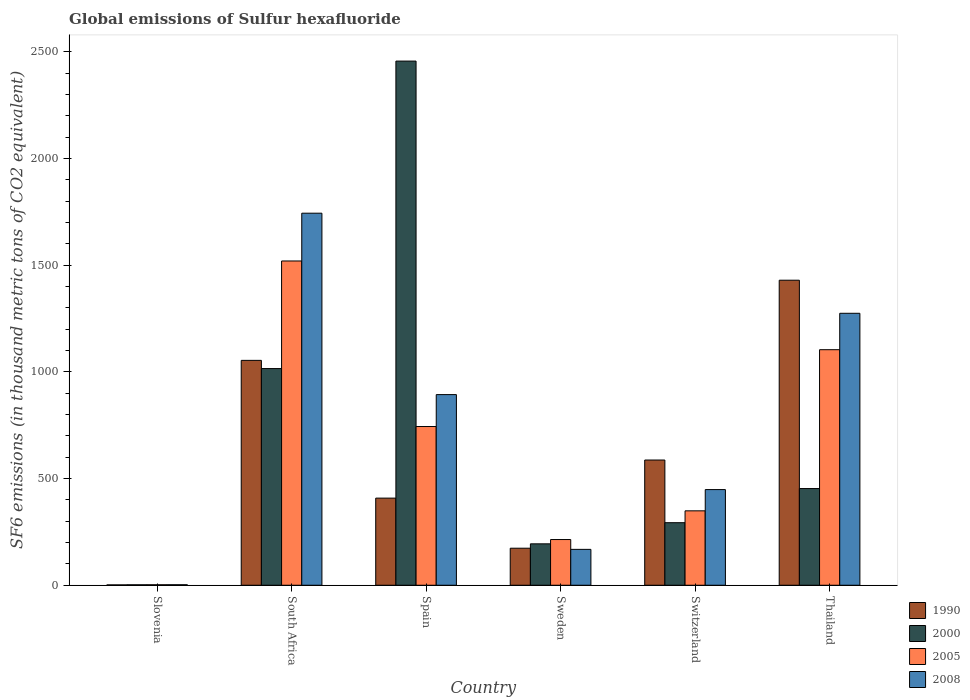Are the number of bars per tick equal to the number of legend labels?
Make the answer very short. Yes. Are the number of bars on each tick of the X-axis equal?
Offer a very short reply. Yes. How many bars are there on the 2nd tick from the left?
Provide a short and direct response. 4. How many bars are there on the 2nd tick from the right?
Your answer should be very brief. 4. In how many cases, is the number of bars for a given country not equal to the number of legend labels?
Give a very brief answer. 0. What is the global emissions of Sulfur hexafluoride in 2008 in Switzerland?
Give a very brief answer. 448.3. Across all countries, what is the maximum global emissions of Sulfur hexafluoride in 2008?
Your answer should be compact. 1743.6. In which country was the global emissions of Sulfur hexafluoride in 2005 maximum?
Your answer should be very brief. South Africa. In which country was the global emissions of Sulfur hexafluoride in 2008 minimum?
Your answer should be very brief. Slovenia. What is the total global emissions of Sulfur hexafluoride in 2000 in the graph?
Your answer should be compact. 4414.1. What is the difference between the global emissions of Sulfur hexafluoride in 2000 in South Africa and that in Switzerland?
Offer a very short reply. 722.3. What is the difference between the global emissions of Sulfur hexafluoride in 1990 in Sweden and the global emissions of Sulfur hexafluoride in 2008 in Slovenia?
Your answer should be compact. 171.2. What is the average global emissions of Sulfur hexafluoride in 2000 per country?
Offer a very short reply. 735.68. What is the difference between the global emissions of Sulfur hexafluoride of/in 2008 and global emissions of Sulfur hexafluoride of/in 2005 in South Africa?
Offer a terse response. 223.9. In how many countries, is the global emissions of Sulfur hexafluoride in 1990 greater than 2000 thousand metric tons?
Give a very brief answer. 0. What is the ratio of the global emissions of Sulfur hexafluoride in 1990 in South Africa to that in Sweden?
Your answer should be compact. 6.07. Is the global emissions of Sulfur hexafluoride in 1990 in Spain less than that in Thailand?
Provide a succinct answer. Yes. Is the difference between the global emissions of Sulfur hexafluoride in 2008 in Sweden and Thailand greater than the difference between the global emissions of Sulfur hexafluoride in 2005 in Sweden and Thailand?
Offer a terse response. No. What is the difference between the highest and the second highest global emissions of Sulfur hexafluoride in 2000?
Offer a very short reply. 2003.4. What is the difference between the highest and the lowest global emissions of Sulfur hexafluoride in 2008?
Keep it short and to the point. 1741.3. What does the 1st bar from the left in Sweden represents?
Provide a short and direct response. 1990. Are all the bars in the graph horizontal?
Provide a succinct answer. No. How many countries are there in the graph?
Ensure brevity in your answer.  6. Does the graph contain grids?
Your answer should be compact. No. What is the title of the graph?
Offer a very short reply. Global emissions of Sulfur hexafluoride. Does "1994" appear as one of the legend labels in the graph?
Your answer should be compact. No. What is the label or title of the Y-axis?
Your response must be concise. SF6 emissions (in thousand metric tons of CO2 equivalent). What is the SF6 emissions (in thousand metric tons of CO2 equivalent) of 1990 in Slovenia?
Ensure brevity in your answer.  1.6. What is the SF6 emissions (in thousand metric tons of CO2 equivalent) in 2000 in Slovenia?
Keep it short and to the point. 2. What is the SF6 emissions (in thousand metric tons of CO2 equivalent) of 2005 in Slovenia?
Offer a terse response. 2.2. What is the SF6 emissions (in thousand metric tons of CO2 equivalent) in 2008 in Slovenia?
Offer a very short reply. 2.3. What is the SF6 emissions (in thousand metric tons of CO2 equivalent) of 1990 in South Africa?
Your response must be concise. 1053.9. What is the SF6 emissions (in thousand metric tons of CO2 equivalent) in 2000 in South Africa?
Your response must be concise. 1015.4. What is the SF6 emissions (in thousand metric tons of CO2 equivalent) in 2005 in South Africa?
Provide a succinct answer. 1519.7. What is the SF6 emissions (in thousand metric tons of CO2 equivalent) in 2008 in South Africa?
Ensure brevity in your answer.  1743.6. What is the SF6 emissions (in thousand metric tons of CO2 equivalent) in 1990 in Spain?
Give a very brief answer. 408.3. What is the SF6 emissions (in thousand metric tons of CO2 equivalent) of 2000 in Spain?
Ensure brevity in your answer.  2456.5. What is the SF6 emissions (in thousand metric tons of CO2 equivalent) in 2005 in Spain?
Your answer should be very brief. 743.8. What is the SF6 emissions (in thousand metric tons of CO2 equivalent) in 2008 in Spain?
Offer a very short reply. 893.4. What is the SF6 emissions (in thousand metric tons of CO2 equivalent) in 1990 in Sweden?
Ensure brevity in your answer.  173.5. What is the SF6 emissions (in thousand metric tons of CO2 equivalent) of 2000 in Sweden?
Provide a short and direct response. 194. What is the SF6 emissions (in thousand metric tons of CO2 equivalent) of 2005 in Sweden?
Make the answer very short. 214.2. What is the SF6 emissions (in thousand metric tons of CO2 equivalent) in 2008 in Sweden?
Keep it short and to the point. 168.1. What is the SF6 emissions (in thousand metric tons of CO2 equivalent) in 1990 in Switzerland?
Your answer should be compact. 586.8. What is the SF6 emissions (in thousand metric tons of CO2 equivalent) in 2000 in Switzerland?
Ensure brevity in your answer.  293.1. What is the SF6 emissions (in thousand metric tons of CO2 equivalent) of 2005 in Switzerland?
Your answer should be compact. 348.7. What is the SF6 emissions (in thousand metric tons of CO2 equivalent) in 2008 in Switzerland?
Keep it short and to the point. 448.3. What is the SF6 emissions (in thousand metric tons of CO2 equivalent) of 1990 in Thailand?
Ensure brevity in your answer.  1429.5. What is the SF6 emissions (in thousand metric tons of CO2 equivalent) in 2000 in Thailand?
Your answer should be compact. 453.1. What is the SF6 emissions (in thousand metric tons of CO2 equivalent) in 2005 in Thailand?
Provide a succinct answer. 1103.9. What is the SF6 emissions (in thousand metric tons of CO2 equivalent) in 2008 in Thailand?
Offer a very short reply. 1274.5. Across all countries, what is the maximum SF6 emissions (in thousand metric tons of CO2 equivalent) of 1990?
Your answer should be compact. 1429.5. Across all countries, what is the maximum SF6 emissions (in thousand metric tons of CO2 equivalent) of 2000?
Keep it short and to the point. 2456.5. Across all countries, what is the maximum SF6 emissions (in thousand metric tons of CO2 equivalent) in 2005?
Offer a terse response. 1519.7. Across all countries, what is the maximum SF6 emissions (in thousand metric tons of CO2 equivalent) of 2008?
Your answer should be compact. 1743.6. Across all countries, what is the minimum SF6 emissions (in thousand metric tons of CO2 equivalent) in 1990?
Provide a short and direct response. 1.6. Across all countries, what is the minimum SF6 emissions (in thousand metric tons of CO2 equivalent) in 2000?
Your answer should be compact. 2. Across all countries, what is the minimum SF6 emissions (in thousand metric tons of CO2 equivalent) of 2008?
Keep it short and to the point. 2.3. What is the total SF6 emissions (in thousand metric tons of CO2 equivalent) of 1990 in the graph?
Keep it short and to the point. 3653.6. What is the total SF6 emissions (in thousand metric tons of CO2 equivalent) of 2000 in the graph?
Ensure brevity in your answer.  4414.1. What is the total SF6 emissions (in thousand metric tons of CO2 equivalent) of 2005 in the graph?
Your response must be concise. 3932.5. What is the total SF6 emissions (in thousand metric tons of CO2 equivalent) in 2008 in the graph?
Provide a short and direct response. 4530.2. What is the difference between the SF6 emissions (in thousand metric tons of CO2 equivalent) of 1990 in Slovenia and that in South Africa?
Your response must be concise. -1052.3. What is the difference between the SF6 emissions (in thousand metric tons of CO2 equivalent) in 2000 in Slovenia and that in South Africa?
Offer a terse response. -1013.4. What is the difference between the SF6 emissions (in thousand metric tons of CO2 equivalent) in 2005 in Slovenia and that in South Africa?
Offer a very short reply. -1517.5. What is the difference between the SF6 emissions (in thousand metric tons of CO2 equivalent) in 2008 in Slovenia and that in South Africa?
Make the answer very short. -1741.3. What is the difference between the SF6 emissions (in thousand metric tons of CO2 equivalent) of 1990 in Slovenia and that in Spain?
Provide a short and direct response. -406.7. What is the difference between the SF6 emissions (in thousand metric tons of CO2 equivalent) in 2000 in Slovenia and that in Spain?
Make the answer very short. -2454.5. What is the difference between the SF6 emissions (in thousand metric tons of CO2 equivalent) of 2005 in Slovenia and that in Spain?
Make the answer very short. -741.6. What is the difference between the SF6 emissions (in thousand metric tons of CO2 equivalent) in 2008 in Slovenia and that in Spain?
Give a very brief answer. -891.1. What is the difference between the SF6 emissions (in thousand metric tons of CO2 equivalent) in 1990 in Slovenia and that in Sweden?
Ensure brevity in your answer.  -171.9. What is the difference between the SF6 emissions (in thousand metric tons of CO2 equivalent) in 2000 in Slovenia and that in Sweden?
Offer a very short reply. -192. What is the difference between the SF6 emissions (in thousand metric tons of CO2 equivalent) of 2005 in Slovenia and that in Sweden?
Your answer should be very brief. -212. What is the difference between the SF6 emissions (in thousand metric tons of CO2 equivalent) of 2008 in Slovenia and that in Sweden?
Your response must be concise. -165.8. What is the difference between the SF6 emissions (in thousand metric tons of CO2 equivalent) of 1990 in Slovenia and that in Switzerland?
Offer a terse response. -585.2. What is the difference between the SF6 emissions (in thousand metric tons of CO2 equivalent) of 2000 in Slovenia and that in Switzerland?
Offer a very short reply. -291.1. What is the difference between the SF6 emissions (in thousand metric tons of CO2 equivalent) of 2005 in Slovenia and that in Switzerland?
Your answer should be compact. -346.5. What is the difference between the SF6 emissions (in thousand metric tons of CO2 equivalent) in 2008 in Slovenia and that in Switzerland?
Ensure brevity in your answer.  -446. What is the difference between the SF6 emissions (in thousand metric tons of CO2 equivalent) of 1990 in Slovenia and that in Thailand?
Your answer should be very brief. -1427.9. What is the difference between the SF6 emissions (in thousand metric tons of CO2 equivalent) of 2000 in Slovenia and that in Thailand?
Offer a terse response. -451.1. What is the difference between the SF6 emissions (in thousand metric tons of CO2 equivalent) of 2005 in Slovenia and that in Thailand?
Give a very brief answer. -1101.7. What is the difference between the SF6 emissions (in thousand metric tons of CO2 equivalent) of 2008 in Slovenia and that in Thailand?
Your response must be concise. -1272.2. What is the difference between the SF6 emissions (in thousand metric tons of CO2 equivalent) of 1990 in South Africa and that in Spain?
Offer a terse response. 645.6. What is the difference between the SF6 emissions (in thousand metric tons of CO2 equivalent) of 2000 in South Africa and that in Spain?
Offer a very short reply. -1441.1. What is the difference between the SF6 emissions (in thousand metric tons of CO2 equivalent) in 2005 in South Africa and that in Spain?
Offer a terse response. 775.9. What is the difference between the SF6 emissions (in thousand metric tons of CO2 equivalent) in 2008 in South Africa and that in Spain?
Your answer should be compact. 850.2. What is the difference between the SF6 emissions (in thousand metric tons of CO2 equivalent) of 1990 in South Africa and that in Sweden?
Ensure brevity in your answer.  880.4. What is the difference between the SF6 emissions (in thousand metric tons of CO2 equivalent) in 2000 in South Africa and that in Sweden?
Offer a very short reply. 821.4. What is the difference between the SF6 emissions (in thousand metric tons of CO2 equivalent) of 2005 in South Africa and that in Sweden?
Give a very brief answer. 1305.5. What is the difference between the SF6 emissions (in thousand metric tons of CO2 equivalent) of 2008 in South Africa and that in Sweden?
Ensure brevity in your answer.  1575.5. What is the difference between the SF6 emissions (in thousand metric tons of CO2 equivalent) of 1990 in South Africa and that in Switzerland?
Ensure brevity in your answer.  467.1. What is the difference between the SF6 emissions (in thousand metric tons of CO2 equivalent) in 2000 in South Africa and that in Switzerland?
Provide a succinct answer. 722.3. What is the difference between the SF6 emissions (in thousand metric tons of CO2 equivalent) of 2005 in South Africa and that in Switzerland?
Offer a terse response. 1171. What is the difference between the SF6 emissions (in thousand metric tons of CO2 equivalent) in 2008 in South Africa and that in Switzerland?
Your response must be concise. 1295.3. What is the difference between the SF6 emissions (in thousand metric tons of CO2 equivalent) in 1990 in South Africa and that in Thailand?
Make the answer very short. -375.6. What is the difference between the SF6 emissions (in thousand metric tons of CO2 equivalent) in 2000 in South Africa and that in Thailand?
Offer a very short reply. 562.3. What is the difference between the SF6 emissions (in thousand metric tons of CO2 equivalent) in 2005 in South Africa and that in Thailand?
Make the answer very short. 415.8. What is the difference between the SF6 emissions (in thousand metric tons of CO2 equivalent) in 2008 in South Africa and that in Thailand?
Offer a terse response. 469.1. What is the difference between the SF6 emissions (in thousand metric tons of CO2 equivalent) in 1990 in Spain and that in Sweden?
Provide a succinct answer. 234.8. What is the difference between the SF6 emissions (in thousand metric tons of CO2 equivalent) in 2000 in Spain and that in Sweden?
Keep it short and to the point. 2262.5. What is the difference between the SF6 emissions (in thousand metric tons of CO2 equivalent) of 2005 in Spain and that in Sweden?
Offer a very short reply. 529.6. What is the difference between the SF6 emissions (in thousand metric tons of CO2 equivalent) of 2008 in Spain and that in Sweden?
Keep it short and to the point. 725.3. What is the difference between the SF6 emissions (in thousand metric tons of CO2 equivalent) of 1990 in Spain and that in Switzerland?
Provide a succinct answer. -178.5. What is the difference between the SF6 emissions (in thousand metric tons of CO2 equivalent) in 2000 in Spain and that in Switzerland?
Ensure brevity in your answer.  2163.4. What is the difference between the SF6 emissions (in thousand metric tons of CO2 equivalent) in 2005 in Spain and that in Switzerland?
Provide a short and direct response. 395.1. What is the difference between the SF6 emissions (in thousand metric tons of CO2 equivalent) of 2008 in Spain and that in Switzerland?
Make the answer very short. 445.1. What is the difference between the SF6 emissions (in thousand metric tons of CO2 equivalent) of 1990 in Spain and that in Thailand?
Give a very brief answer. -1021.2. What is the difference between the SF6 emissions (in thousand metric tons of CO2 equivalent) in 2000 in Spain and that in Thailand?
Offer a terse response. 2003.4. What is the difference between the SF6 emissions (in thousand metric tons of CO2 equivalent) in 2005 in Spain and that in Thailand?
Keep it short and to the point. -360.1. What is the difference between the SF6 emissions (in thousand metric tons of CO2 equivalent) in 2008 in Spain and that in Thailand?
Make the answer very short. -381.1. What is the difference between the SF6 emissions (in thousand metric tons of CO2 equivalent) of 1990 in Sweden and that in Switzerland?
Offer a terse response. -413.3. What is the difference between the SF6 emissions (in thousand metric tons of CO2 equivalent) of 2000 in Sweden and that in Switzerland?
Offer a very short reply. -99.1. What is the difference between the SF6 emissions (in thousand metric tons of CO2 equivalent) of 2005 in Sweden and that in Switzerland?
Your response must be concise. -134.5. What is the difference between the SF6 emissions (in thousand metric tons of CO2 equivalent) in 2008 in Sweden and that in Switzerland?
Provide a succinct answer. -280.2. What is the difference between the SF6 emissions (in thousand metric tons of CO2 equivalent) in 1990 in Sweden and that in Thailand?
Your answer should be compact. -1256. What is the difference between the SF6 emissions (in thousand metric tons of CO2 equivalent) of 2000 in Sweden and that in Thailand?
Your answer should be very brief. -259.1. What is the difference between the SF6 emissions (in thousand metric tons of CO2 equivalent) of 2005 in Sweden and that in Thailand?
Give a very brief answer. -889.7. What is the difference between the SF6 emissions (in thousand metric tons of CO2 equivalent) in 2008 in Sweden and that in Thailand?
Your response must be concise. -1106.4. What is the difference between the SF6 emissions (in thousand metric tons of CO2 equivalent) in 1990 in Switzerland and that in Thailand?
Provide a short and direct response. -842.7. What is the difference between the SF6 emissions (in thousand metric tons of CO2 equivalent) of 2000 in Switzerland and that in Thailand?
Offer a terse response. -160. What is the difference between the SF6 emissions (in thousand metric tons of CO2 equivalent) in 2005 in Switzerland and that in Thailand?
Make the answer very short. -755.2. What is the difference between the SF6 emissions (in thousand metric tons of CO2 equivalent) in 2008 in Switzerland and that in Thailand?
Ensure brevity in your answer.  -826.2. What is the difference between the SF6 emissions (in thousand metric tons of CO2 equivalent) of 1990 in Slovenia and the SF6 emissions (in thousand metric tons of CO2 equivalent) of 2000 in South Africa?
Give a very brief answer. -1013.8. What is the difference between the SF6 emissions (in thousand metric tons of CO2 equivalent) of 1990 in Slovenia and the SF6 emissions (in thousand metric tons of CO2 equivalent) of 2005 in South Africa?
Your answer should be compact. -1518.1. What is the difference between the SF6 emissions (in thousand metric tons of CO2 equivalent) in 1990 in Slovenia and the SF6 emissions (in thousand metric tons of CO2 equivalent) in 2008 in South Africa?
Offer a very short reply. -1742. What is the difference between the SF6 emissions (in thousand metric tons of CO2 equivalent) of 2000 in Slovenia and the SF6 emissions (in thousand metric tons of CO2 equivalent) of 2005 in South Africa?
Offer a terse response. -1517.7. What is the difference between the SF6 emissions (in thousand metric tons of CO2 equivalent) of 2000 in Slovenia and the SF6 emissions (in thousand metric tons of CO2 equivalent) of 2008 in South Africa?
Offer a terse response. -1741.6. What is the difference between the SF6 emissions (in thousand metric tons of CO2 equivalent) of 2005 in Slovenia and the SF6 emissions (in thousand metric tons of CO2 equivalent) of 2008 in South Africa?
Your answer should be compact. -1741.4. What is the difference between the SF6 emissions (in thousand metric tons of CO2 equivalent) of 1990 in Slovenia and the SF6 emissions (in thousand metric tons of CO2 equivalent) of 2000 in Spain?
Your answer should be very brief. -2454.9. What is the difference between the SF6 emissions (in thousand metric tons of CO2 equivalent) of 1990 in Slovenia and the SF6 emissions (in thousand metric tons of CO2 equivalent) of 2005 in Spain?
Make the answer very short. -742.2. What is the difference between the SF6 emissions (in thousand metric tons of CO2 equivalent) of 1990 in Slovenia and the SF6 emissions (in thousand metric tons of CO2 equivalent) of 2008 in Spain?
Offer a very short reply. -891.8. What is the difference between the SF6 emissions (in thousand metric tons of CO2 equivalent) in 2000 in Slovenia and the SF6 emissions (in thousand metric tons of CO2 equivalent) in 2005 in Spain?
Keep it short and to the point. -741.8. What is the difference between the SF6 emissions (in thousand metric tons of CO2 equivalent) of 2000 in Slovenia and the SF6 emissions (in thousand metric tons of CO2 equivalent) of 2008 in Spain?
Provide a short and direct response. -891.4. What is the difference between the SF6 emissions (in thousand metric tons of CO2 equivalent) of 2005 in Slovenia and the SF6 emissions (in thousand metric tons of CO2 equivalent) of 2008 in Spain?
Offer a very short reply. -891.2. What is the difference between the SF6 emissions (in thousand metric tons of CO2 equivalent) of 1990 in Slovenia and the SF6 emissions (in thousand metric tons of CO2 equivalent) of 2000 in Sweden?
Keep it short and to the point. -192.4. What is the difference between the SF6 emissions (in thousand metric tons of CO2 equivalent) of 1990 in Slovenia and the SF6 emissions (in thousand metric tons of CO2 equivalent) of 2005 in Sweden?
Your answer should be very brief. -212.6. What is the difference between the SF6 emissions (in thousand metric tons of CO2 equivalent) of 1990 in Slovenia and the SF6 emissions (in thousand metric tons of CO2 equivalent) of 2008 in Sweden?
Ensure brevity in your answer.  -166.5. What is the difference between the SF6 emissions (in thousand metric tons of CO2 equivalent) of 2000 in Slovenia and the SF6 emissions (in thousand metric tons of CO2 equivalent) of 2005 in Sweden?
Offer a terse response. -212.2. What is the difference between the SF6 emissions (in thousand metric tons of CO2 equivalent) in 2000 in Slovenia and the SF6 emissions (in thousand metric tons of CO2 equivalent) in 2008 in Sweden?
Give a very brief answer. -166.1. What is the difference between the SF6 emissions (in thousand metric tons of CO2 equivalent) in 2005 in Slovenia and the SF6 emissions (in thousand metric tons of CO2 equivalent) in 2008 in Sweden?
Keep it short and to the point. -165.9. What is the difference between the SF6 emissions (in thousand metric tons of CO2 equivalent) of 1990 in Slovenia and the SF6 emissions (in thousand metric tons of CO2 equivalent) of 2000 in Switzerland?
Make the answer very short. -291.5. What is the difference between the SF6 emissions (in thousand metric tons of CO2 equivalent) in 1990 in Slovenia and the SF6 emissions (in thousand metric tons of CO2 equivalent) in 2005 in Switzerland?
Your answer should be very brief. -347.1. What is the difference between the SF6 emissions (in thousand metric tons of CO2 equivalent) in 1990 in Slovenia and the SF6 emissions (in thousand metric tons of CO2 equivalent) in 2008 in Switzerland?
Your response must be concise. -446.7. What is the difference between the SF6 emissions (in thousand metric tons of CO2 equivalent) in 2000 in Slovenia and the SF6 emissions (in thousand metric tons of CO2 equivalent) in 2005 in Switzerland?
Provide a succinct answer. -346.7. What is the difference between the SF6 emissions (in thousand metric tons of CO2 equivalent) in 2000 in Slovenia and the SF6 emissions (in thousand metric tons of CO2 equivalent) in 2008 in Switzerland?
Keep it short and to the point. -446.3. What is the difference between the SF6 emissions (in thousand metric tons of CO2 equivalent) of 2005 in Slovenia and the SF6 emissions (in thousand metric tons of CO2 equivalent) of 2008 in Switzerland?
Offer a very short reply. -446.1. What is the difference between the SF6 emissions (in thousand metric tons of CO2 equivalent) of 1990 in Slovenia and the SF6 emissions (in thousand metric tons of CO2 equivalent) of 2000 in Thailand?
Provide a short and direct response. -451.5. What is the difference between the SF6 emissions (in thousand metric tons of CO2 equivalent) in 1990 in Slovenia and the SF6 emissions (in thousand metric tons of CO2 equivalent) in 2005 in Thailand?
Make the answer very short. -1102.3. What is the difference between the SF6 emissions (in thousand metric tons of CO2 equivalent) of 1990 in Slovenia and the SF6 emissions (in thousand metric tons of CO2 equivalent) of 2008 in Thailand?
Keep it short and to the point. -1272.9. What is the difference between the SF6 emissions (in thousand metric tons of CO2 equivalent) in 2000 in Slovenia and the SF6 emissions (in thousand metric tons of CO2 equivalent) in 2005 in Thailand?
Ensure brevity in your answer.  -1101.9. What is the difference between the SF6 emissions (in thousand metric tons of CO2 equivalent) of 2000 in Slovenia and the SF6 emissions (in thousand metric tons of CO2 equivalent) of 2008 in Thailand?
Give a very brief answer. -1272.5. What is the difference between the SF6 emissions (in thousand metric tons of CO2 equivalent) of 2005 in Slovenia and the SF6 emissions (in thousand metric tons of CO2 equivalent) of 2008 in Thailand?
Offer a terse response. -1272.3. What is the difference between the SF6 emissions (in thousand metric tons of CO2 equivalent) of 1990 in South Africa and the SF6 emissions (in thousand metric tons of CO2 equivalent) of 2000 in Spain?
Ensure brevity in your answer.  -1402.6. What is the difference between the SF6 emissions (in thousand metric tons of CO2 equivalent) in 1990 in South Africa and the SF6 emissions (in thousand metric tons of CO2 equivalent) in 2005 in Spain?
Your answer should be compact. 310.1. What is the difference between the SF6 emissions (in thousand metric tons of CO2 equivalent) in 1990 in South Africa and the SF6 emissions (in thousand metric tons of CO2 equivalent) in 2008 in Spain?
Your response must be concise. 160.5. What is the difference between the SF6 emissions (in thousand metric tons of CO2 equivalent) of 2000 in South Africa and the SF6 emissions (in thousand metric tons of CO2 equivalent) of 2005 in Spain?
Your answer should be very brief. 271.6. What is the difference between the SF6 emissions (in thousand metric tons of CO2 equivalent) of 2000 in South Africa and the SF6 emissions (in thousand metric tons of CO2 equivalent) of 2008 in Spain?
Provide a short and direct response. 122. What is the difference between the SF6 emissions (in thousand metric tons of CO2 equivalent) in 2005 in South Africa and the SF6 emissions (in thousand metric tons of CO2 equivalent) in 2008 in Spain?
Offer a very short reply. 626.3. What is the difference between the SF6 emissions (in thousand metric tons of CO2 equivalent) in 1990 in South Africa and the SF6 emissions (in thousand metric tons of CO2 equivalent) in 2000 in Sweden?
Your answer should be very brief. 859.9. What is the difference between the SF6 emissions (in thousand metric tons of CO2 equivalent) of 1990 in South Africa and the SF6 emissions (in thousand metric tons of CO2 equivalent) of 2005 in Sweden?
Ensure brevity in your answer.  839.7. What is the difference between the SF6 emissions (in thousand metric tons of CO2 equivalent) of 1990 in South Africa and the SF6 emissions (in thousand metric tons of CO2 equivalent) of 2008 in Sweden?
Ensure brevity in your answer.  885.8. What is the difference between the SF6 emissions (in thousand metric tons of CO2 equivalent) of 2000 in South Africa and the SF6 emissions (in thousand metric tons of CO2 equivalent) of 2005 in Sweden?
Make the answer very short. 801.2. What is the difference between the SF6 emissions (in thousand metric tons of CO2 equivalent) of 2000 in South Africa and the SF6 emissions (in thousand metric tons of CO2 equivalent) of 2008 in Sweden?
Make the answer very short. 847.3. What is the difference between the SF6 emissions (in thousand metric tons of CO2 equivalent) of 2005 in South Africa and the SF6 emissions (in thousand metric tons of CO2 equivalent) of 2008 in Sweden?
Give a very brief answer. 1351.6. What is the difference between the SF6 emissions (in thousand metric tons of CO2 equivalent) in 1990 in South Africa and the SF6 emissions (in thousand metric tons of CO2 equivalent) in 2000 in Switzerland?
Offer a very short reply. 760.8. What is the difference between the SF6 emissions (in thousand metric tons of CO2 equivalent) in 1990 in South Africa and the SF6 emissions (in thousand metric tons of CO2 equivalent) in 2005 in Switzerland?
Offer a terse response. 705.2. What is the difference between the SF6 emissions (in thousand metric tons of CO2 equivalent) of 1990 in South Africa and the SF6 emissions (in thousand metric tons of CO2 equivalent) of 2008 in Switzerland?
Keep it short and to the point. 605.6. What is the difference between the SF6 emissions (in thousand metric tons of CO2 equivalent) in 2000 in South Africa and the SF6 emissions (in thousand metric tons of CO2 equivalent) in 2005 in Switzerland?
Make the answer very short. 666.7. What is the difference between the SF6 emissions (in thousand metric tons of CO2 equivalent) in 2000 in South Africa and the SF6 emissions (in thousand metric tons of CO2 equivalent) in 2008 in Switzerland?
Provide a short and direct response. 567.1. What is the difference between the SF6 emissions (in thousand metric tons of CO2 equivalent) of 2005 in South Africa and the SF6 emissions (in thousand metric tons of CO2 equivalent) of 2008 in Switzerland?
Ensure brevity in your answer.  1071.4. What is the difference between the SF6 emissions (in thousand metric tons of CO2 equivalent) of 1990 in South Africa and the SF6 emissions (in thousand metric tons of CO2 equivalent) of 2000 in Thailand?
Give a very brief answer. 600.8. What is the difference between the SF6 emissions (in thousand metric tons of CO2 equivalent) in 1990 in South Africa and the SF6 emissions (in thousand metric tons of CO2 equivalent) in 2008 in Thailand?
Give a very brief answer. -220.6. What is the difference between the SF6 emissions (in thousand metric tons of CO2 equivalent) in 2000 in South Africa and the SF6 emissions (in thousand metric tons of CO2 equivalent) in 2005 in Thailand?
Your answer should be compact. -88.5. What is the difference between the SF6 emissions (in thousand metric tons of CO2 equivalent) of 2000 in South Africa and the SF6 emissions (in thousand metric tons of CO2 equivalent) of 2008 in Thailand?
Provide a succinct answer. -259.1. What is the difference between the SF6 emissions (in thousand metric tons of CO2 equivalent) in 2005 in South Africa and the SF6 emissions (in thousand metric tons of CO2 equivalent) in 2008 in Thailand?
Provide a succinct answer. 245.2. What is the difference between the SF6 emissions (in thousand metric tons of CO2 equivalent) in 1990 in Spain and the SF6 emissions (in thousand metric tons of CO2 equivalent) in 2000 in Sweden?
Make the answer very short. 214.3. What is the difference between the SF6 emissions (in thousand metric tons of CO2 equivalent) in 1990 in Spain and the SF6 emissions (in thousand metric tons of CO2 equivalent) in 2005 in Sweden?
Your response must be concise. 194.1. What is the difference between the SF6 emissions (in thousand metric tons of CO2 equivalent) of 1990 in Spain and the SF6 emissions (in thousand metric tons of CO2 equivalent) of 2008 in Sweden?
Offer a very short reply. 240.2. What is the difference between the SF6 emissions (in thousand metric tons of CO2 equivalent) of 2000 in Spain and the SF6 emissions (in thousand metric tons of CO2 equivalent) of 2005 in Sweden?
Keep it short and to the point. 2242.3. What is the difference between the SF6 emissions (in thousand metric tons of CO2 equivalent) in 2000 in Spain and the SF6 emissions (in thousand metric tons of CO2 equivalent) in 2008 in Sweden?
Ensure brevity in your answer.  2288.4. What is the difference between the SF6 emissions (in thousand metric tons of CO2 equivalent) in 2005 in Spain and the SF6 emissions (in thousand metric tons of CO2 equivalent) in 2008 in Sweden?
Give a very brief answer. 575.7. What is the difference between the SF6 emissions (in thousand metric tons of CO2 equivalent) of 1990 in Spain and the SF6 emissions (in thousand metric tons of CO2 equivalent) of 2000 in Switzerland?
Offer a terse response. 115.2. What is the difference between the SF6 emissions (in thousand metric tons of CO2 equivalent) in 1990 in Spain and the SF6 emissions (in thousand metric tons of CO2 equivalent) in 2005 in Switzerland?
Your response must be concise. 59.6. What is the difference between the SF6 emissions (in thousand metric tons of CO2 equivalent) of 1990 in Spain and the SF6 emissions (in thousand metric tons of CO2 equivalent) of 2008 in Switzerland?
Your response must be concise. -40. What is the difference between the SF6 emissions (in thousand metric tons of CO2 equivalent) of 2000 in Spain and the SF6 emissions (in thousand metric tons of CO2 equivalent) of 2005 in Switzerland?
Provide a succinct answer. 2107.8. What is the difference between the SF6 emissions (in thousand metric tons of CO2 equivalent) in 2000 in Spain and the SF6 emissions (in thousand metric tons of CO2 equivalent) in 2008 in Switzerland?
Make the answer very short. 2008.2. What is the difference between the SF6 emissions (in thousand metric tons of CO2 equivalent) in 2005 in Spain and the SF6 emissions (in thousand metric tons of CO2 equivalent) in 2008 in Switzerland?
Make the answer very short. 295.5. What is the difference between the SF6 emissions (in thousand metric tons of CO2 equivalent) of 1990 in Spain and the SF6 emissions (in thousand metric tons of CO2 equivalent) of 2000 in Thailand?
Your answer should be very brief. -44.8. What is the difference between the SF6 emissions (in thousand metric tons of CO2 equivalent) in 1990 in Spain and the SF6 emissions (in thousand metric tons of CO2 equivalent) in 2005 in Thailand?
Keep it short and to the point. -695.6. What is the difference between the SF6 emissions (in thousand metric tons of CO2 equivalent) of 1990 in Spain and the SF6 emissions (in thousand metric tons of CO2 equivalent) of 2008 in Thailand?
Offer a terse response. -866.2. What is the difference between the SF6 emissions (in thousand metric tons of CO2 equivalent) of 2000 in Spain and the SF6 emissions (in thousand metric tons of CO2 equivalent) of 2005 in Thailand?
Make the answer very short. 1352.6. What is the difference between the SF6 emissions (in thousand metric tons of CO2 equivalent) in 2000 in Spain and the SF6 emissions (in thousand metric tons of CO2 equivalent) in 2008 in Thailand?
Your response must be concise. 1182. What is the difference between the SF6 emissions (in thousand metric tons of CO2 equivalent) in 2005 in Spain and the SF6 emissions (in thousand metric tons of CO2 equivalent) in 2008 in Thailand?
Provide a succinct answer. -530.7. What is the difference between the SF6 emissions (in thousand metric tons of CO2 equivalent) of 1990 in Sweden and the SF6 emissions (in thousand metric tons of CO2 equivalent) of 2000 in Switzerland?
Provide a succinct answer. -119.6. What is the difference between the SF6 emissions (in thousand metric tons of CO2 equivalent) in 1990 in Sweden and the SF6 emissions (in thousand metric tons of CO2 equivalent) in 2005 in Switzerland?
Your answer should be compact. -175.2. What is the difference between the SF6 emissions (in thousand metric tons of CO2 equivalent) of 1990 in Sweden and the SF6 emissions (in thousand metric tons of CO2 equivalent) of 2008 in Switzerland?
Make the answer very short. -274.8. What is the difference between the SF6 emissions (in thousand metric tons of CO2 equivalent) of 2000 in Sweden and the SF6 emissions (in thousand metric tons of CO2 equivalent) of 2005 in Switzerland?
Give a very brief answer. -154.7. What is the difference between the SF6 emissions (in thousand metric tons of CO2 equivalent) of 2000 in Sweden and the SF6 emissions (in thousand metric tons of CO2 equivalent) of 2008 in Switzerland?
Your answer should be compact. -254.3. What is the difference between the SF6 emissions (in thousand metric tons of CO2 equivalent) of 2005 in Sweden and the SF6 emissions (in thousand metric tons of CO2 equivalent) of 2008 in Switzerland?
Your answer should be very brief. -234.1. What is the difference between the SF6 emissions (in thousand metric tons of CO2 equivalent) of 1990 in Sweden and the SF6 emissions (in thousand metric tons of CO2 equivalent) of 2000 in Thailand?
Your response must be concise. -279.6. What is the difference between the SF6 emissions (in thousand metric tons of CO2 equivalent) of 1990 in Sweden and the SF6 emissions (in thousand metric tons of CO2 equivalent) of 2005 in Thailand?
Your answer should be very brief. -930.4. What is the difference between the SF6 emissions (in thousand metric tons of CO2 equivalent) in 1990 in Sweden and the SF6 emissions (in thousand metric tons of CO2 equivalent) in 2008 in Thailand?
Offer a very short reply. -1101. What is the difference between the SF6 emissions (in thousand metric tons of CO2 equivalent) of 2000 in Sweden and the SF6 emissions (in thousand metric tons of CO2 equivalent) of 2005 in Thailand?
Your response must be concise. -909.9. What is the difference between the SF6 emissions (in thousand metric tons of CO2 equivalent) of 2000 in Sweden and the SF6 emissions (in thousand metric tons of CO2 equivalent) of 2008 in Thailand?
Ensure brevity in your answer.  -1080.5. What is the difference between the SF6 emissions (in thousand metric tons of CO2 equivalent) in 2005 in Sweden and the SF6 emissions (in thousand metric tons of CO2 equivalent) in 2008 in Thailand?
Your answer should be compact. -1060.3. What is the difference between the SF6 emissions (in thousand metric tons of CO2 equivalent) in 1990 in Switzerland and the SF6 emissions (in thousand metric tons of CO2 equivalent) in 2000 in Thailand?
Provide a succinct answer. 133.7. What is the difference between the SF6 emissions (in thousand metric tons of CO2 equivalent) in 1990 in Switzerland and the SF6 emissions (in thousand metric tons of CO2 equivalent) in 2005 in Thailand?
Your answer should be compact. -517.1. What is the difference between the SF6 emissions (in thousand metric tons of CO2 equivalent) of 1990 in Switzerland and the SF6 emissions (in thousand metric tons of CO2 equivalent) of 2008 in Thailand?
Your answer should be compact. -687.7. What is the difference between the SF6 emissions (in thousand metric tons of CO2 equivalent) in 2000 in Switzerland and the SF6 emissions (in thousand metric tons of CO2 equivalent) in 2005 in Thailand?
Ensure brevity in your answer.  -810.8. What is the difference between the SF6 emissions (in thousand metric tons of CO2 equivalent) of 2000 in Switzerland and the SF6 emissions (in thousand metric tons of CO2 equivalent) of 2008 in Thailand?
Make the answer very short. -981.4. What is the difference between the SF6 emissions (in thousand metric tons of CO2 equivalent) in 2005 in Switzerland and the SF6 emissions (in thousand metric tons of CO2 equivalent) in 2008 in Thailand?
Provide a succinct answer. -925.8. What is the average SF6 emissions (in thousand metric tons of CO2 equivalent) of 1990 per country?
Your response must be concise. 608.93. What is the average SF6 emissions (in thousand metric tons of CO2 equivalent) in 2000 per country?
Offer a terse response. 735.68. What is the average SF6 emissions (in thousand metric tons of CO2 equivalent) in 2005 per country?
Your answer should be compact. 655.42. What is the average SF6 emissions (in thousand metric tons of CO2 equivalent) of 2008 per country?
Provide a short and direct response. 755.03. What is the difference between the SF6 emissions (in thousand metric tons of CO2 equivalent) in 1990 and SF6 emissions (in thousand metric tons of CO2 equivalent) in 2000 in Slovenia?
Offer a very short reply. -0.4. What is the difference between the SF6 emissions (in thousand metric tons of CO2 equivalent) of 1990 and SF6 emissions (in thousand metric tons of CO2 equivalent) of 2005 in Slovenia?
Provide a succinct answer. -0.6. What is the difference between the SF6 emissions (in thousand metric tons of CO2 equivalent) of 2000 and SF6 emissions (in thousand metric tons of CO2 equivalent) of 2005 in Slovenia?
Make the answer very short. -0.2. What is the difference between the SF6 emissions (in thousand metric tons of CO2 equivalent) in 1990 and SF6 emissions (in thousand metric tons of CO2 equivalent) in 2000 in South Africa?
Keep it short and to the point. 38.5. What is the difference between the SF6 emissions (in thousand metric tons of CO2 equivalent) in 1990 and SF6 emissions (in thousand metric tons of CO2 equivalent) in 2005 in South Africa?
Your answer should be compact. -465.8. What is the difference between the SF6 emissions (in thousand metric tons of CO2 equivalent) of 1990 and SF6 emissions (in thousand metric tons of CO2 equivalent) of 2008 in South Africa?
Make the answer very short. -689.7. What is the difference between the SF6 emissions (in thousand metric tons of CO2 equivalent) in 2000 and SF6 emissions (in thousand metric tons of CO2 equivalent) in 2005 in South Africa?
Give a very brief answer. -504.3. What is the difference between the SF6 emissions (in thousand metric tons of CO2 equivalent) in 2000 and SF6 emissions (in thousand metric tons of CO2 equivalent) in 2008 in South Africa?
Provide a succinct answer. -728.2. What is the difference between the SF6 emissions (in thousand metric tons of CO2 equivalent) in 2005 and SF6 emissions (in thousand metric tons of CO2 equivalent) in 2008 in South Africa?
Give a very brief answer. -223.9. What is the difference between the SF6 emissions (in thousand metric tons of CO2 equivalent) in 1990 and SF6 emissions (in thousand metric tons of CO2 equivalent) in 2000 in Spain?
Offer a very short reply. -2048.2. What is the difference between the SF6 emissions (in thousand metric tons of CO2 equivalent) in 1990 and SF6 emissions (in thousand metric tons of CO2 equivalent) in 2005 in Spain?
Offer a very short reply. -335.5. What is the difference between the SF6 emissions (in thousand metric tons of CO2 equivalent) of 1990 and SF6 emissions (in thousand metric tons of CO2 equivalent) of 2008 in Spain?
Your answer should be compact. -485.1. What is the difference between the SF6 emissions (in thousand metric tons of CO2 equivalent) of 2000 and SF6 emissions (in thousand metric tons of CO2 equivalent) of 2005 in Spain?
Your answer should be very brief. 1712.7. What is the difference between the SF6 emissions (in thousand metric tons of CO2 equivalent) in 2000 and SF6 emissions (in thousand metric tons of CO2 equivalent) in 2008 in Spain?
Your answer should be very brief. 1563.1. What is the difference between the SF6 emissions (in thousand metric tons of CO2 equivalent) in 2005 and SF6 emissions (in thousand metric tons of CO2 equivalent) in 2008 in Spain?
Ensure brevity in your answer.  -149.6. What is the difference between the SF6 emissions (in thousand metric tons of CO2 equivalent) in 1990 and SF6 emissions (in thousand metric tons of CO2 equivalent) in 2000 in Sweden?
Your response must be concise. -20.5. What is the difference between the SF6 emissions (in thousand metric tons of CO2 equivalent) of 1990 and SF6 emissions (in thousand metric tons of CO2 equivalent) of 2005 in Sweden?
Give a very brief answer. -40.7. What is the difference between the SF6 emissions (in thousand metric tons of CO2 equivalent) of 2000 and SF6 emissions (in thousand metric tons of CO2 equivalent) of 2005 in Sweden?
Offer a terse response. -20.2. What is the difference between the SF6 emissions (in thousand metric tons of CO2 equivalent) in 2000 and SF6 emissions (in thousand metric tons of CO2 equivalent) in 2008 in Sweden?
Keep it short and to the point. 25.9. What is the difference between the SF6 emissions (in thousand metric tons of CO2 equivalent) in 2005 and SF6 emissions (in thousand metric tons of CO2 equivalent) in 2008 in Sweden?
Provide a succinct answer. 46.1. What is the difference between the SF6 emissions (in thousand metric tons of CO2 equivalent) of 1990 and SF6 emissions (in thousand metric tons of CO2 equivalent) of 2000 in Switzerland?
Make the answer very short. 293.7. What is the difference between the SF6 emissions (in thousand metric tons of CO2 equivalent) of 1990 and SF6 emissions (in thousand metric tons of CO2 equivalent) of 2005 in Switzerland?
Offer a terse response. 238.1. What is the difference between the SF6 emissions (in thousand metric tons of CO2 equivalent) of 1990 and SF6 emissions (in thousand metric tons of CO2 equivalent) of 2008 in Switzerland?
Offer a very short reply. 138.5. What is the difference between the SF6 emissions (in thousand metric tons of CO2 equivalent) of 2000 and SF6 emissions (in thousand metric tons of CO2 equivalent) of 2005 in Switzerland?
Offer a terse response. -55.6. What is the difference between the SF6 emissions (in thousand metric tons of CO2 equivalent) of 2000 and SF6 emissions (in thousand metric tons of CO2 equivalent) of 2008 in Switzerland?
Provide a short and direct response. -155.2. What is the difference between the SF6 emissions (in thousand metric tons of CO2 equivalent) in 2005 and SF6 emissions (in thousand metric tons of CO2 equivalent) in 2008 in Switzerland?
Your response must be concise. -99.6. What is the difference between the SF6 emissions (in thousand metric tons of CO2 equivalent) in 1990 and SF6 emissions (in thousand metric tons of CO2 equivalent) in 2000 in Thailand?
Your response must be concise. 976.4. What is the difference between the SF6 emissions (in thousand metric tons of CO2 equivalent) of 1990 and SF6 emissions (in thousand metric tons of CO2 equivalent) of 2005 in Thailand?
Provide a succinct answer. 325.6. What is the difference between the SF6 emissions (in thousand metric tons of CO2 equivalent) of 1990 and SF6 emissions (in thousand metric tons of CO2 equivalent) of 2008 in Thailand?
Ensure brevity in your answer.  155. What is the difference between the SF6 emissions (in thousand metric tons of CO2 equivalent) in 2000 and SF6 emissions (in thousand metric tons of CO2 equivalent) in 2005 in Thailand?
Offer a terse response. -650.8. What is the difference between the SF6 emissions (in thousand metric tons of CO2 equivalent) of 2000 and SF6 emissions (in thousand metric tons of CO2 equivalent) of 2008 in Thailand?
Your answer should be compact. -821.4. What is the difference between the SF6 emissions (in thousand metric tons of CO2 equivalent) of 2005 and SF6 emissions (in thousand metric tons of CO2 equivalent) of 2008 in Thailand?
Your answer should be compact. -170.6. What is the ratio of the SF6 emissions (in thousand metric tons of CO2 equivalent) of 1990 in Slovenia to that in South Africa?
Your answer should be compact. 0. What is the ratio of the SF6 emissions (in thousand metric tons of CO2 equivalent) in 2000 in Slovenia to that in South Africa?
Make the answer very short. 0. What is the ratio of the SF6 emissions (in thousand metric tons of CO2 equivalent) of 2005 in Slovenia to that in South Africa?
Offer a terse response. 0. What is the ratio of the SF6 emissions (in thousand metric tons of CO2 equivalent) in 2008 in Slovenia to that in South Africa?
Make the answer very short. 0. What is the ratio of the SF6 emissions (in thousand metric tons of CO2 equivalent) of 1990 in Slovenia to that in Spain?
Give a very brief answer. 0. What is the ratio of the SF6 emissions (in thousand metric tons of CO2 equivalent) in 2000 in Slovenia to that in Spain?
Keep it short and to the point. 0. What is the ratio of the SF6 emissions (in thousand metric tons of CO2 equivalent) in 2005 in Slovenia to that in Spain?
Offer a very short reply. 0. What is the ratio of the SF6 emissions (in thousand metric tons of CO2 equivalent) of 2008 in Slovenia to that in Spain?
Offer a very short reply. 0. What is the ratio of the SF6 emissions (in thousand metric tons of CO2 equivalent) in 1990 in Slovenia to that in Sweden?
Ensure brevity in your answer.  0.01. What is the ratio of the SF6 emissions (in thousand metric tons of CO2 equivalent) of 2000 in Slovenia to that in Sweden?
Offer a terse response. 0.01. What is the ratio of the SF6 emissions (in thousand metric tons of CO2 equivalent) of 2005 in Slovenia to that in Sweden?
Your response must be concise. 0.01. What is the ratio of the SF6 emissions (in thousand metric tons of CO2 equivalent) in 2008 in Slovenia to that in Sweden?
Offer a very short reply. 0.01. What is the ratio of the SF6 emissions (in thousand metric tons of CO2 equivalent) of 1990 in Slovenia to that in Switzerland?
Give a very brief answer. 0. What is the ratio of the SF6 emissions (in thousand metric tons of CO2 equivalent) in 2000 in Slovenia to that in Switzerland?
Your answer should be compact. 0.01. What is the ratio of the SF6 emissions (in thousand metric tons of CO2 equivalent) of 2005 in Slovenia to that in Switzerland?
Provide a short and direct response. 0.01. What is the ratio of the SF6 emissions (in thousand metric tons of CO2 equivalent) in 2008 in Slovenia to that in Switzerland?
Ensure brevity in your answer.  0.01. What is the ratio of the SF6 emissions (in thousand metric tons of CO2 equivalent) in 1990 in Slovenia to that in Thailand?
Keep it short and to the point. 0. What is the ratio of the SF6 emissions (in thousand metric tons of CO2 equivalent) of 2000 in Slovenia to that in Thailand?
Make the answer very short. 0. What is the ratio of the SF6 emissions (in thousand metric tons of CO2 equivalent) of 2005 in Slovenia to that in Thailand?
Your answer should be compact. 0. What is the ratio of the SF6 emissions (in thousand metric tons of CO2 equivalent) in 2008 in Slovenia to that in Thailand?
Provide a short and direct response. 0. What is the ratio of the SF6 emissions (in thousand metric tons of CO2 equivalent) in 1990 in South Africa to that in Spain?
Offer a terse response. 2.58. What is the ratio of the SF6 emissions (in thousand metric tons of CO2 equivalent) in 2000 in South Africa to that in Spain?
Your answer should be compact. 0.41. What is the ratio of the SF6 emissions (in thousand metric tons of CO2 equivalent) of 2005 in South Africa to that in Spain?
Keep it short and to the point. 2.04. What is the ratio of the SF6 emissions (in thousand metric tons of CO2 equivalent) in 2008 in South Africa to that in Spain?
Give a very brief answer. 1.95. What is the ratio of the SF6 emissions (in thousand metric tons of CO2 equivalent) in 1990 in South Africa to that in Sweden?
Your answer should be compact. 6.07. What is the ratio of the SF6 emissions (in thousand metric tons of CO2 equivalent) of 2000 in South Africa to that in Sweden?
Provide a succinct answer. 5.23. What is the ratio of the SF6 emissions (in thousand metric tons of CO2 equivalent) in 2005 in South Africa to that in Sweden?
Keep it short and to the point. 7.09. What is the ratio of the SF6 emissions (in thousand metric tons of CO2 equivalent) of 2008 in South Africa to that in Sweden?
Provide a short and direct response. 10.37. What is the ratio of the SF6 emissions (in thousand metric tons of CO2 equivalent) of 1990 in South Africa to that in Switzerland?
Your response must be concise. 1.8. What is the ratio of the SF6 emissions (in thousand metric tons of CO2 equivalent) of 2000 in South Africa to that in Switzerland?
Keep it short and to the point. 3.46. What is the ratio of the SF6 emissions (in thousand metric tons of CO2 equivalent) of 2005 in South Africa to that in Switzerland?
Offer a terse response. 4.36. What is the ratio of the SF6 emissions (in thousand metric tons of CO2 equivalent) of 2008 in South Africa to that in Switzerland?
Your response must be concise. 3.89. What is the ratio of the SF6 emissions (in thousand metric tons of CO2 equivalent) of 1990 in South Africa to that in Thailand?
Provide a short and direct response. 0.74. What is the ratio of the SF6 emissions (in thousand metric tons of CO2 equivalent) of 2000 in South Africa to that in Thailand?
Make the answer very short. 2.24. What is the ratio of the SF6 emissions (in thousand metric tons of CO2 equivalent) in 2005 in South Africa to that in Thailand?
Provide a succinct answer. 1.38. What is the ratio of the SF6 emissions (in thousand metric tons of CO2 equivalent) of 2008 in South Africa to that in Thailand?
Ensure brevity in your answer.  1.37. What is the ratio of the SF6 emissions (in thousand metric tons of CO2 equivalent) in 1990 in Spain to that in Sweden?
Keep it short and to the point. 2.35. What is the ratio of the SF6 emissions (in thousand metric tons of CO2 equivalent) of 2000 in Spain to that in Sweden?
Ensure brevity in your answer.  12.66. What is the ratio of the SF6 emissions (in thousand metric tons of CO2 equivalent) in 2005 in Spain to that in Sweden?
Make the answer very short. 3.47. What is the ratio of the SF6 emissions (in thousand metric tons of CO2 equivalent) in 2008 in Spain to that in Sweden?
Offer a terse response. 5.31. What is the ratio of the SF6 emissions (in thousand metric tons of CO2 equivalent) of 1990 in Spain to that in Switzerland?
Offer a terse response. 0.7. What is the ratio of the SF6 emissions (in thousand metric tons of CO2 equivalent) of 2000 in Spain to that in Switzerland?
Your response must be concise. 8.38. What is the ratio of the SF6 emissions (in thousand metric tons of CO2 equivalent) of 2005 in Spain to that in Switzerland?
Keep it short and to the point. 2.13. What is the ratio of the SF6 emissions (in thousand metric tons of CO2 equivalent) of 2008 in Spain to that in Switzerland?
Your response must be concise. 1.99. What is the ratio of the SF6 emissions (in thousand metric tons of CO2 equivalent) in 1990 in Spain to that in Thailand?
Make the answer very short. 0.29. What is the ratio of the SF6 emissions (in thousand metric tons of CO2 equivalent) in 2000 in Spain to that in Thailand?
Keep it short and to the point. 5.42. What is the ratio of the SF6 emissions (in thousand metric tons of CO2 equivalent) in 2005 in Spain to that in Thailand?
Ensure brevity in your answer.  0.67. What is the ratio of the SF6 emissions (in thousand metric tons of CO2 equivalent) in 2008 in Spain to that in Thailand?
Give a very brief answer. 0.7. What is the ratio of the SF6 emissions (in thousand metric tons of CO2 equivalent) in 1990 in Sweden to that in Switzerland?
Give a very brief answer. 0.3. What is the ratio of the SF6 emissions (in thousand metric tons of CO2 equivalent) in 2000 in Sweden to that in Switzerland?
Give a very brief answer. 0.66. What is the ratio of the SF6 emissions (in thousand metric tons of CO2 equivalent) in 2005 in Sweden to that in Switzerland?
Your answer should be very brief. 0.61. What is the ratio of the SF6 emissions (in thousand metric tons of CO2 equivalent) of 1990 in Sweden to that in Thailand?
Give a very brief answer. 0.12. What is the ratio of the SF6 emissions (in thousand metric tons of CO2 equivalent) in 2000 in Sweden to that in Thailand?
Your answer should be very brief. 0.43. What is the ratio of the SF6 emissions (in thousand metric tons of CO2 equivalent) in 2005 in Sweden to that in Thailand?
Your answer should be compact. 0.19. What is the ratio of the SF6 emissions (in thousand metric tons of CO2 equivalent) in 2008 in Sweden to that in Thailand?
Provide a succinct answer. 0.13. What is the ratio of the SF6 emissions (in thousand metric tons of CO2 equivalent) of 1990 in Switzerland to that in Thailand?
Your answer should be very brief. 0.41. What is the ratio of the SF6 emissions (in thousand metric tons of CO2 equivalent) of 2000 in Switzerland to that in Thailand?
Provide a succinct answer. 0.65. What is the ratio of the SF6 emissions (in thousand metric tons of CO2 equivalent) in 2005 in Switzerland to that in Thailand?
Make the answer very short. 0.32. What is the ratio of the SF6 emissions (in thousand metric tons of CO2 equivalent) in 2008 in Switzerland to that in Thailand?
Your answer should be compact. 0.35. What is the difference between the highest and the second highest SF6 emissions (in thousand metric tons of CO2 equivalent) of 1990?
Provide a succinct answer. 375.6. What is the difference between the highest and the second highest SF6 emissions (in thousand metric tons of CO2 equivalent) of 2000?
Provide a short and direct response. 1441.1. What is the difference between the highest and the second highest SF6 emissions (in thousand metric tons of CO2 equivalent) of 2005?
Give a very brief answer. 415.8. What is the difference between the highest and the second highest SF6 emissions (in thousand metric tons of CO2 equivalent) in 2008?
Provide a succinct answer. 469.1. What is the difference between the highest and the lowest SF6 emissions (in thousand metric tons of CO2 equivalent) of 1990?
Provide a succinct answer. 1427.9. What is the difference between the highest and the lowest SF6 emissions (in thousand metric tons of CO2 equivalent) in 2000?
Provide a short and direct response. 2454.5. What is the difference between the highest and the lowest SF6 emissions (in thousand metric tons of CO2 equivalent) of 2005?
Your answer should be very brief. 1517.5. What is the difference between the highest and the lowest SF6 emissions (in thousand metric tons of CO2 equivalent) in 2008?
Your answer should be very brief. 1741.3. 